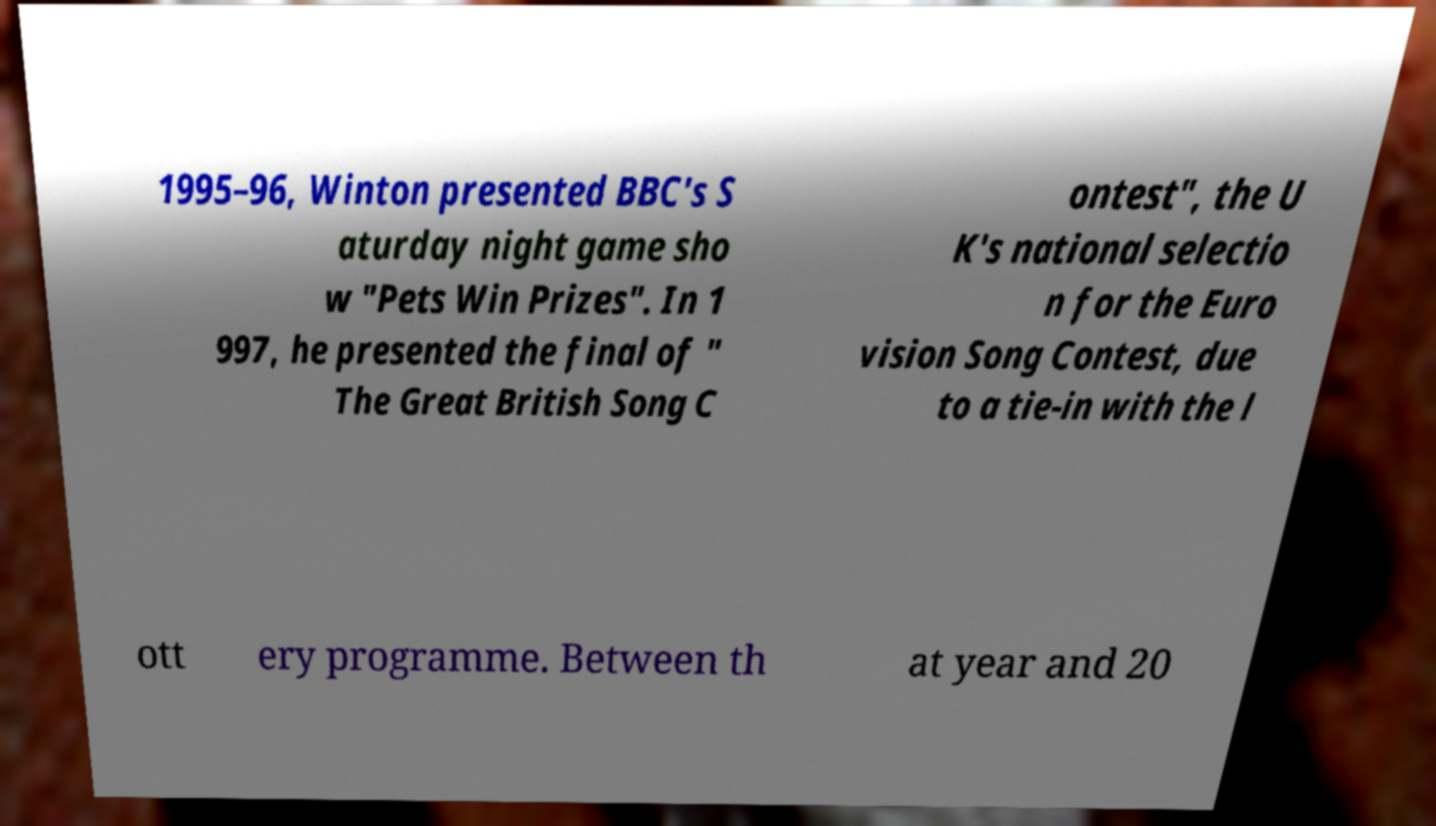Can you accurately transcribe the text from the provided image for me? 1995–96, Winton presented BBC's S aturday night game sho w "Pets Win Prizes". In 1 997, he presented the final of " The Great British Song C ontest", the U K's national selectio n for the Euro vision Song Contest, due to a tie-in with the l ott ery programme. Between th at year and 20 